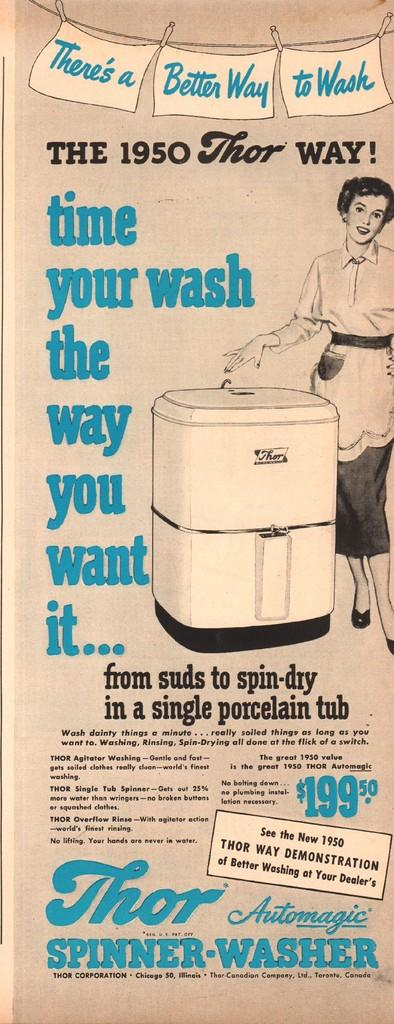<image>
Summarize the visual content of the image. an old paper that says 'the 1950 thor way!' on it 